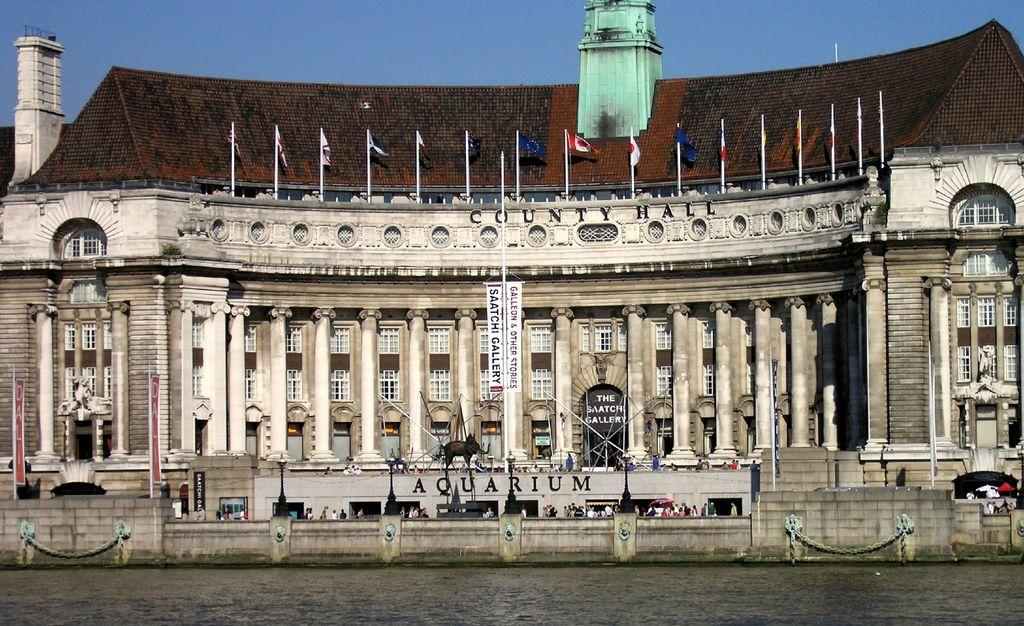What type of structure is present in the image? There is a building in the image. Are there any living beings in the image? Yes, there are people in the image. What can be seen flying in the image? There are flags in the image. What is at the bottom of the image? There is a water surface at the bottom of the image. What is visible at the top of the image? The sky is visible at the top of the image. What language are the bells ringing in the image? There are no bells present in the image, so it is not possible to determine the language they might be ringing in. 